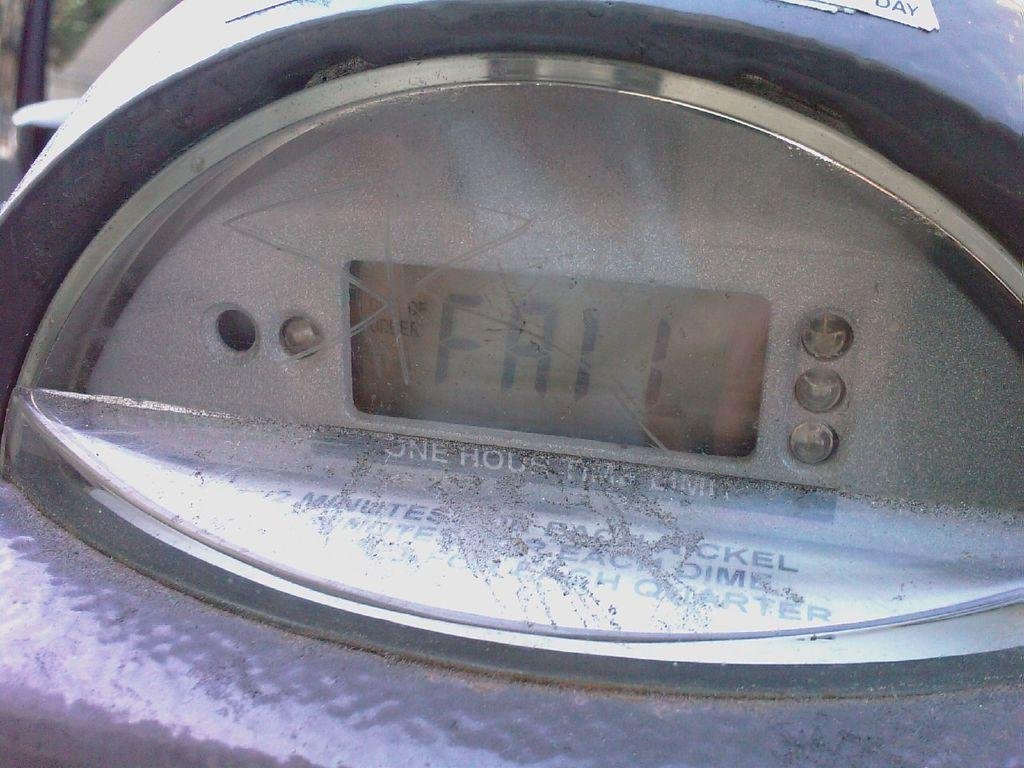<image>
Share a concise interpretation of the image provided. A close up of a parking meter that reads FAIL on it. 